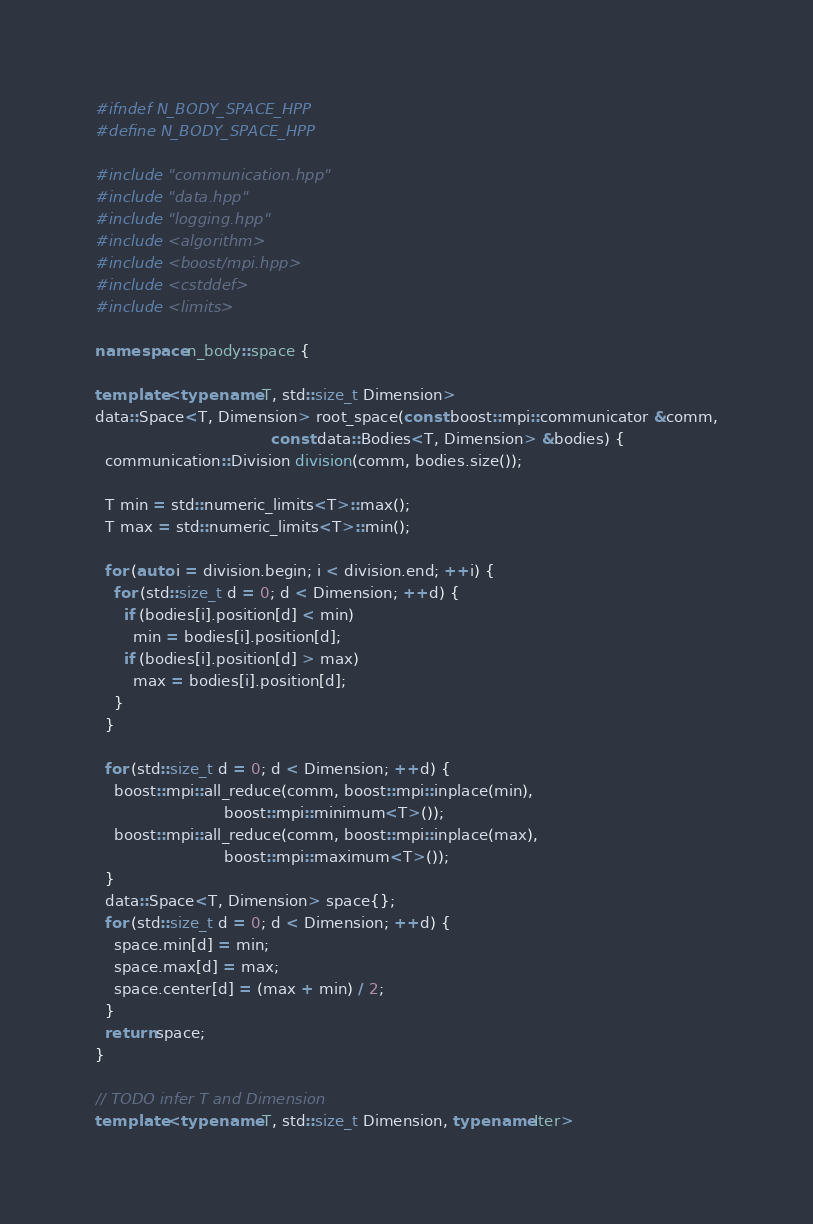Convert code to text. <code><loc_0><loc_0><loc_500><loc_500><_C++_>#ifndef N_BODY_SPACE_HPP
#define N_BODY_SPACE_HPP

#include "communication.hpp"
#include "data.hpp"
#include "logging.hpp"
#include <algorithm>
#include <boost/mpi.hpp>
#include <cstddef>
#include <limits>

namespace n_body::space {

template <typename T, std::size_t Dimension>
data::Space<T, Dimension> root_space(const boost::mpi::communicator &comm,
                                     const data::Bodies<T, Dimension> &bodies) {
  communication::Division division(comm, bodies.size());

  T min = std::numeric_limits<T>::max();
  T max = std::numeric_limits<T>::min();

  for (auto i = division.begin; i < division.end; ++i) {
    for (std::size_t d = 0; d < Dimension; ++d) {
      if (bodies[i].position[d] < min)
        min = bodies[i].position[d];
      if (bodies[i].position[d] > max)
        max = bodies[i].position[d];
    }
  }

  for (std::size_t d = 0; d < Dimension; ++d) {
    boost::mpi::all_reduce(comm, boost::mpi::inplace(min),
                           boost::mpi::minimum<T>());
    boost::mpi::all_reduce(comm, boost::mpi::inplace(max),
                           boost::mpi::maximum<T>());
  }
  data::Space<T, Dimension> space{};
  for (std::size_t d = 0; d < Dimension; ++d) {
    space.min[d] = min;
    space.max[d] = max;
    space.center[d] = (max + min) / 2;
  }
  return space;
}

// TODO infer T and Dimension
template <typename T, std::size_t Dimension, typename Iter></code> 